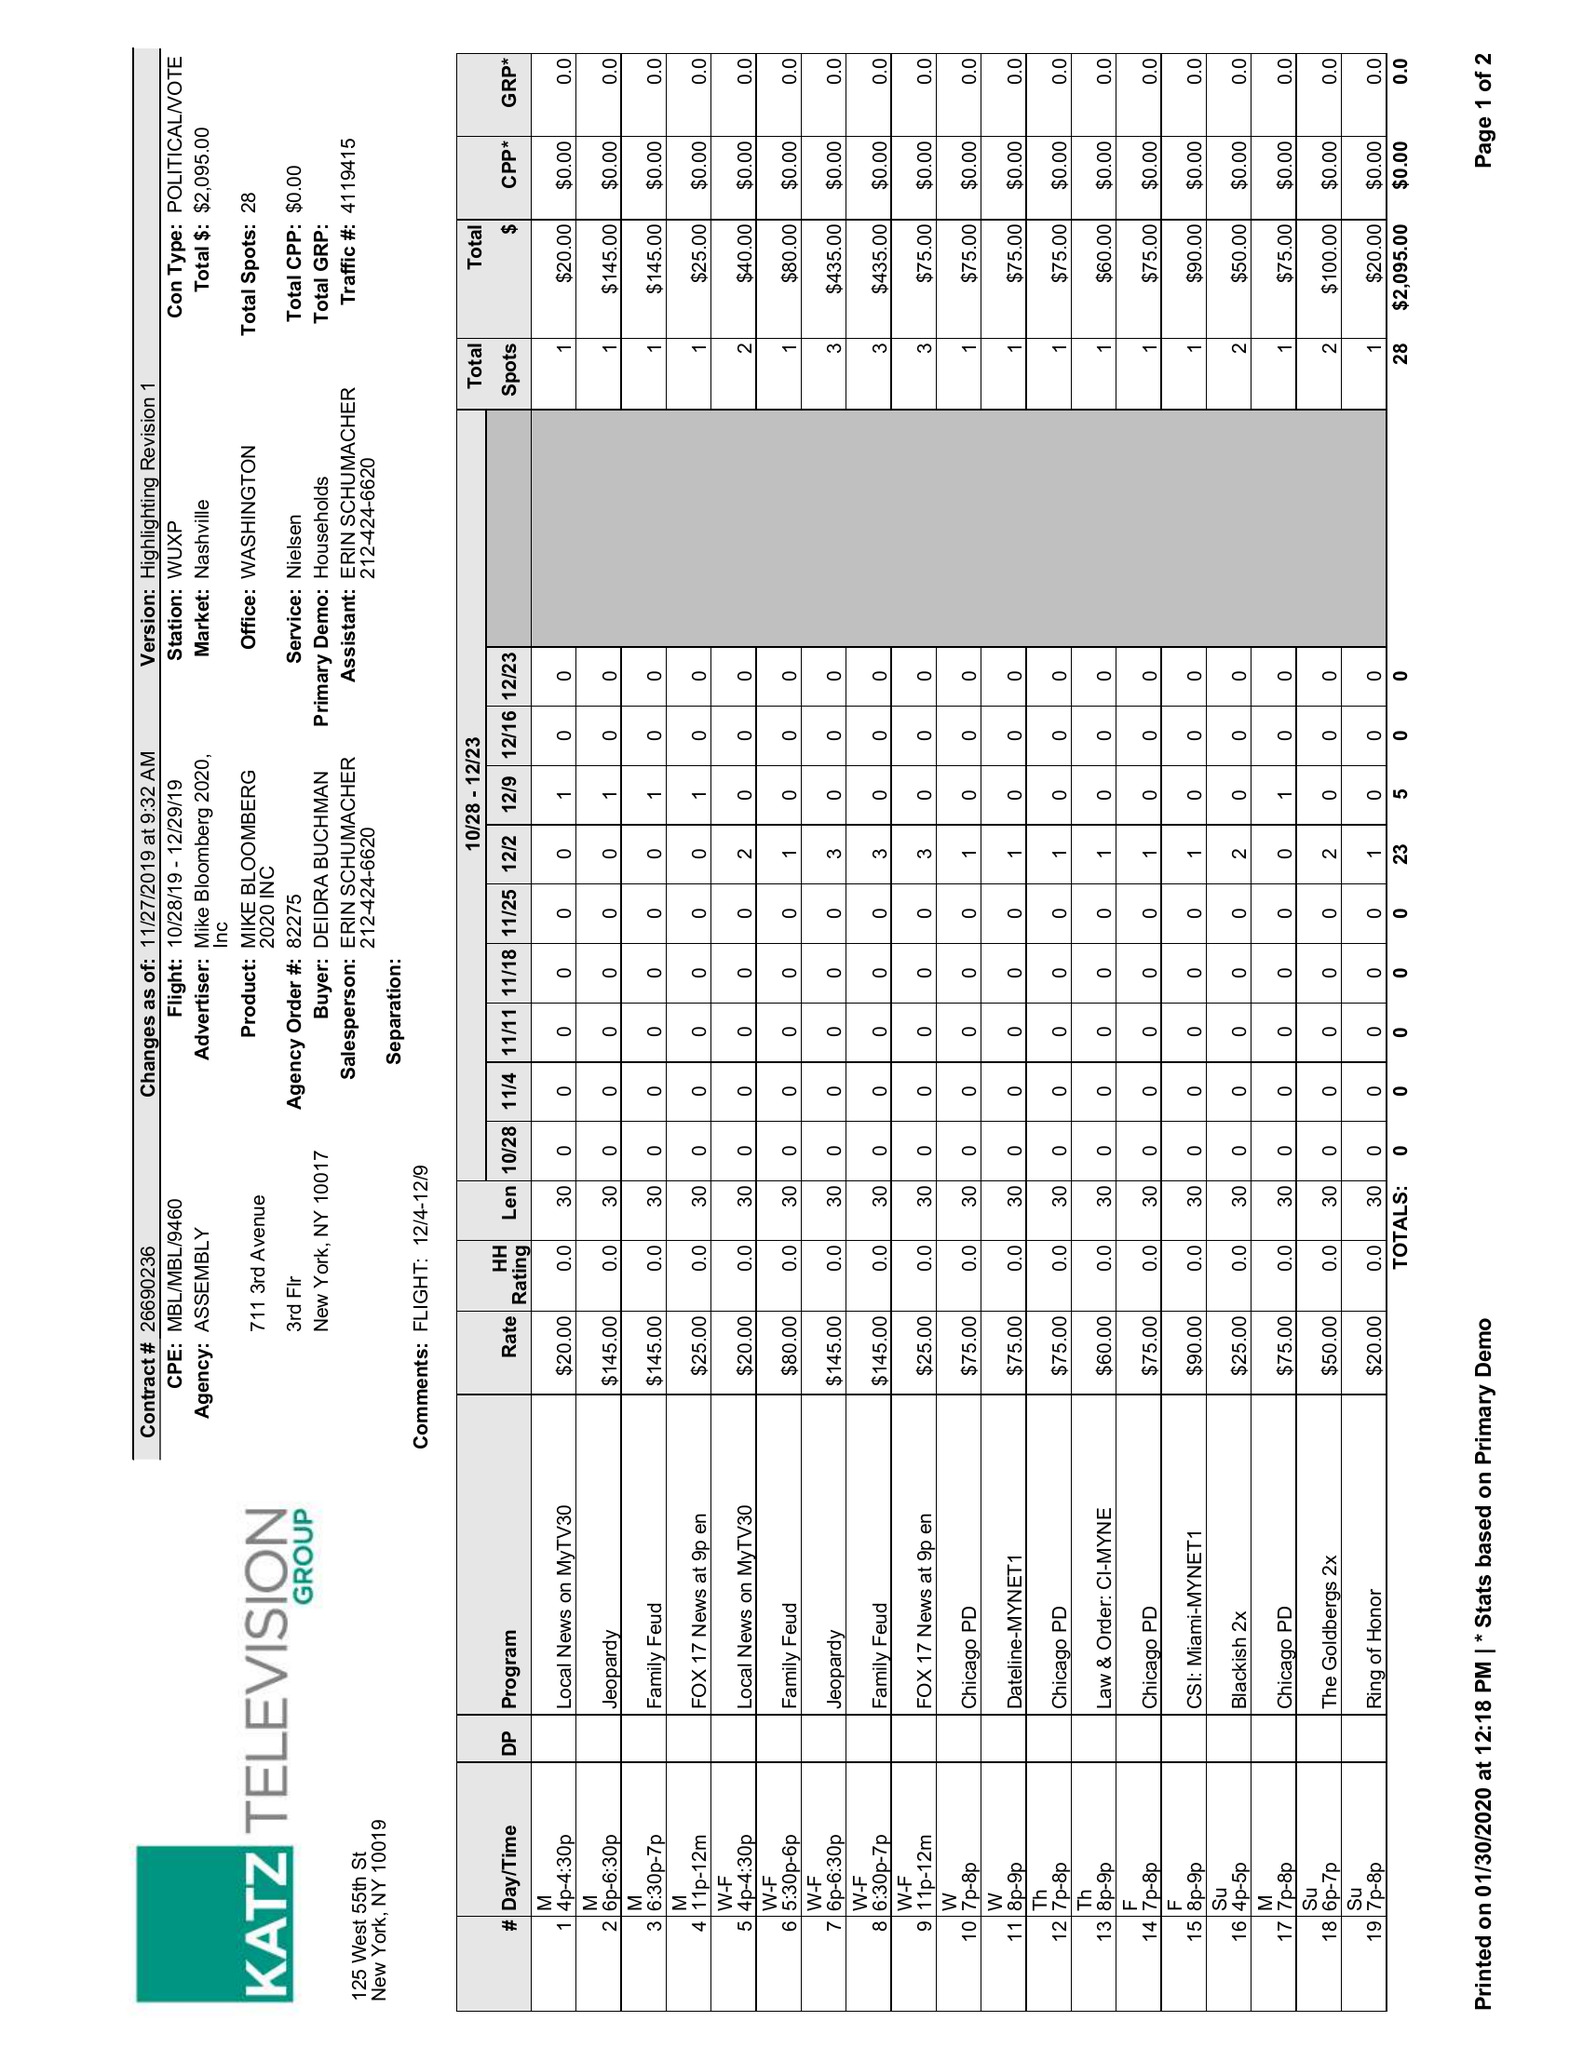What is the value for the flight_from?
Answer the question using a single word or phrase. 10/28/19 